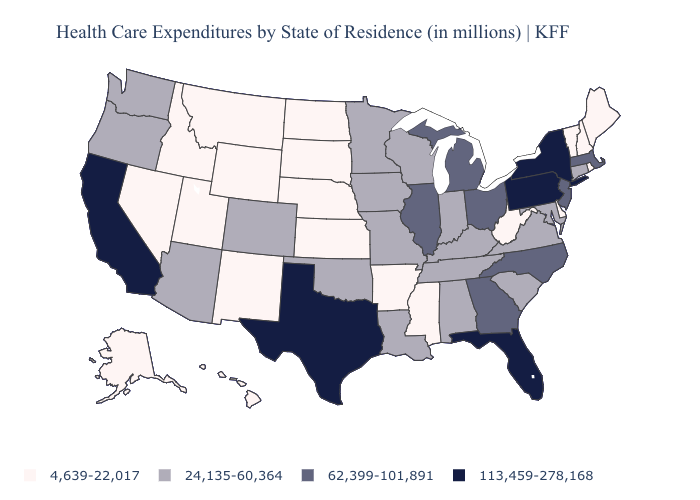What is the highest value in the Northeast ?
Quick response, please. 113,459-278,168. Name the states that have a value in the range 113,459-278,168?
Quick response, please. California, Florida, New York, Pennsylvania, Texas. Among the states that border Oregon , does Nevada have the highest value?
Answer briefly. No. What is the value of Kansas?
Keep it brief. 4,639-22,017. What is the value of Indiana?
Answer briefly. 24,135-60,364. What is the value of New Mexico?
Give a very brief answer. 4,639-22,017. Name the states that have a value in the range 62,399-101,891?
Answer briefly. Georgia, Illinois, Massachusetts, Michigan, New Jersey, North Carolina, Ohio. What is the highest value in the USA?
Quick response, please. 113,459-278,168. How many symbols are there in the legend?
Answer briefly. 4. What is the highest value in the South ?
Be succinct. 113,459-278,168. Does Ohio have a higher value than Maine?
Short answer required. Yes. Among the states that border Arizona , which have the highest value?
Short answer required. California. Name the states that have a value in the range 62,399-101,891?
Write a very short answer. Georgia, Illinois, Massachusetts, Michigan, New Jersey, North Carolina, Ohio. What is the lowest value in the USA?
Keep it brief. 4,639-22,017. Name the states that have a value in the range 24,135-60,364?
Keep it brief. Alabama, Arizona, Colorado, Connecticut, Indiana, Iowa, Kentucky, Louisiana, Maryland, Minnesota, Missouri, Oklahoma, Oregon, South Carolina, Tennessee, Virginia, Washington, Wisconsin. 